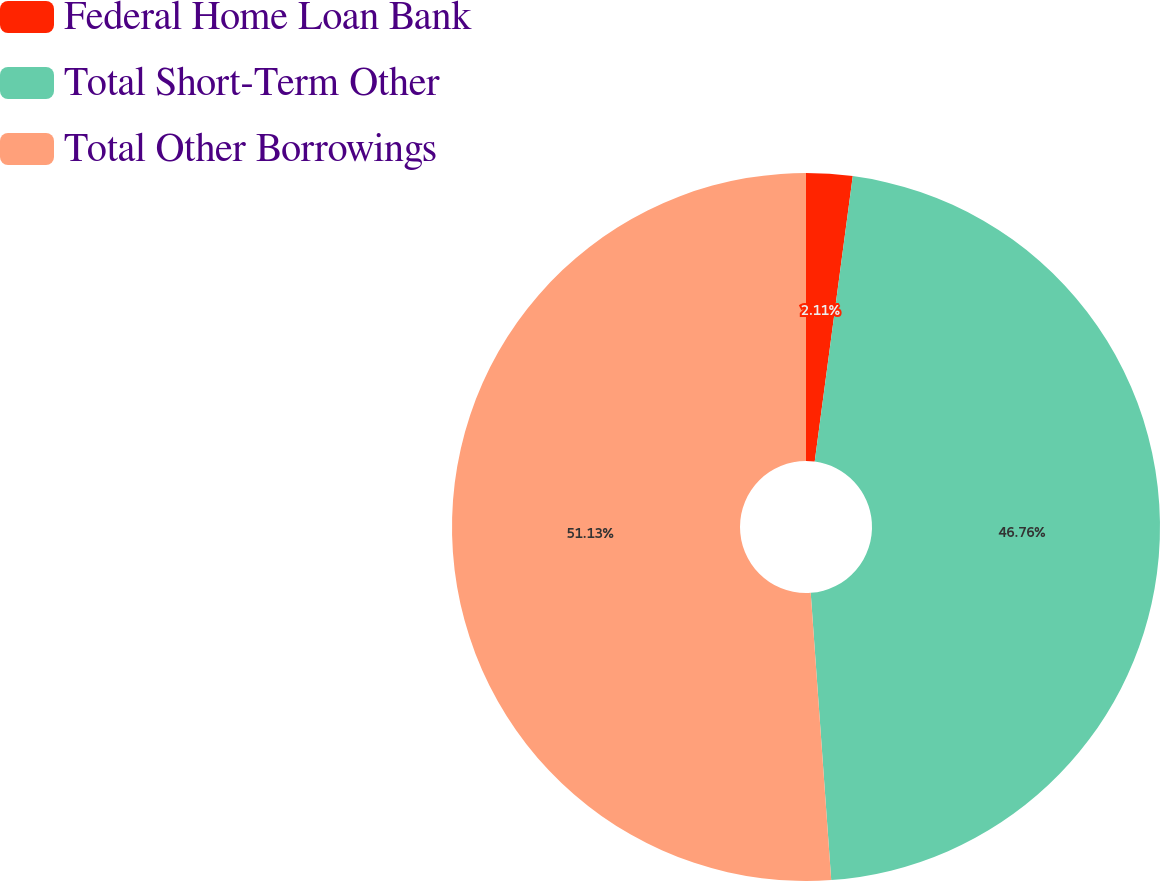<chart> <loc_0><loc_0><loc_500><loc_500><pie_chart><fcel>Federal Home Loan Bank<fcel>Total Short-Term Other<fcel>Total Other Borrowings<nl><fcel>2.11%<fcel>46.76%<fcel>51.14%<nl></chart> 